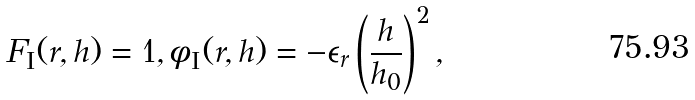Convert formula to latex. <formula><loc_0><loc_0><loc_500><loc_500>F _ { \text {I} } ( r , h ) = 1 , \phi _ { \text {I} } ( r , h ) = - \epsilon _ { r } \left ( \frac { h } { h _ { 0 } } \right ) ^ { 2 } ,</formula> 